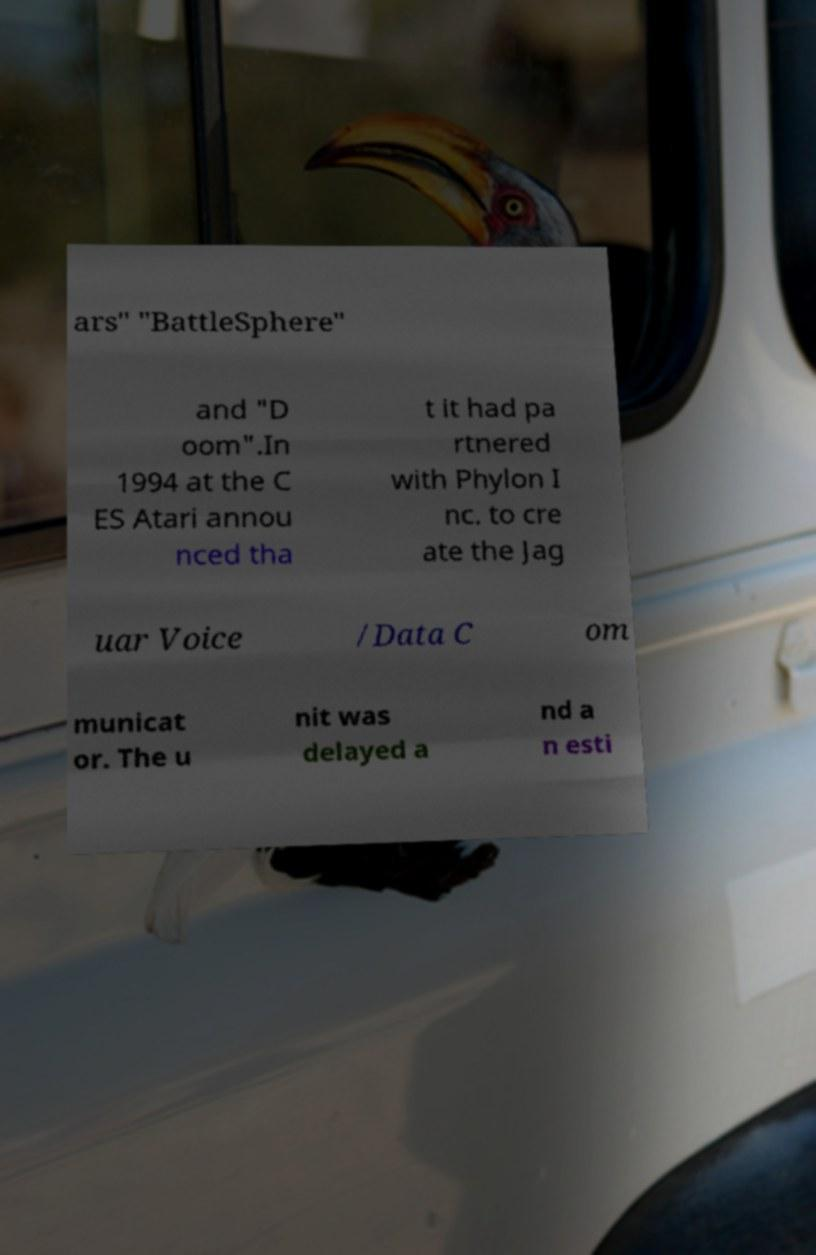For documentation purposes, I need the text within this image transcribed. Could you provide that? ars" "BattleSphere" and "D oom".In 1994 at the C ES Atari annou nced tha t it had pa rtnered with Phylon I nc. to cre ate the Jag uar Voice /Data C om municat or. The u nit was delayed a nd a n esti 